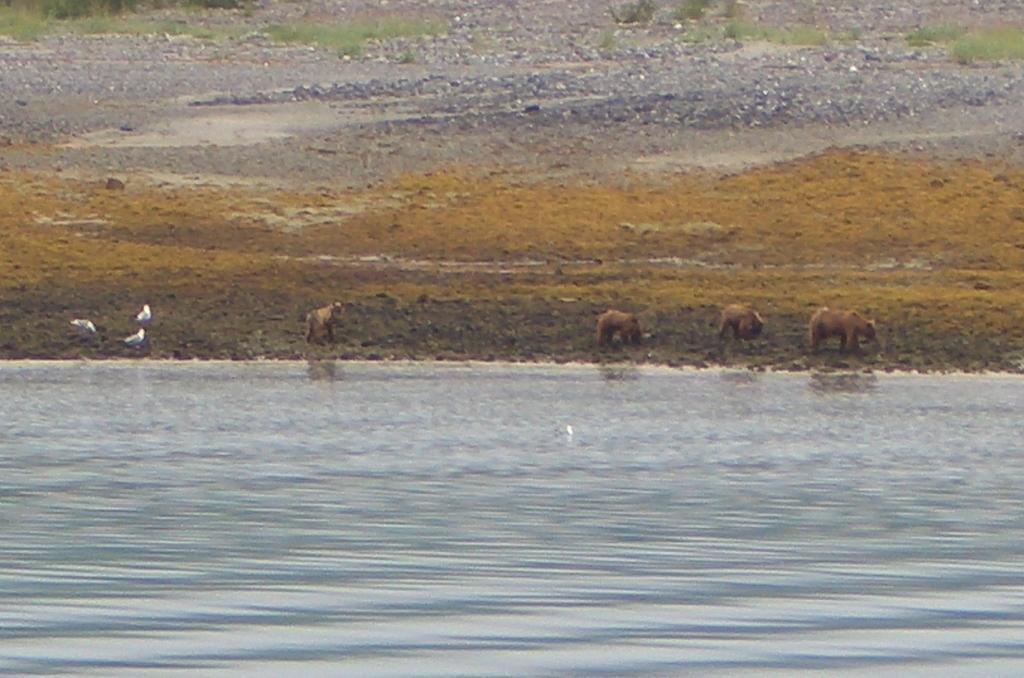How would you summarize this image in a sentence or two? In this image there is water, animals, birds, and in the background there is grass and plants. 